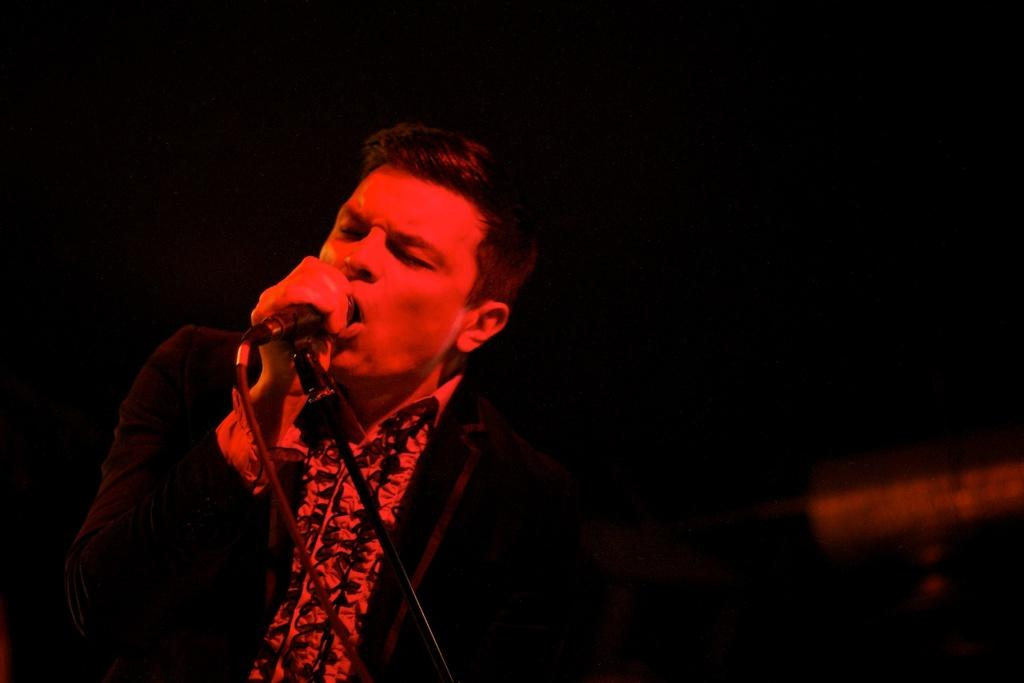What is the main subject of the image? There is a person in the image. What is the person holding in the image? The person is holding a microphone. What is the person doing with the microphone? The person is singing. What can be observed about the background of the image? The background of the image is dark. What type of square can be seen in the image? There is no square present in the image. Is there a truck visible in the image? No, there is no truck visible in the image. 